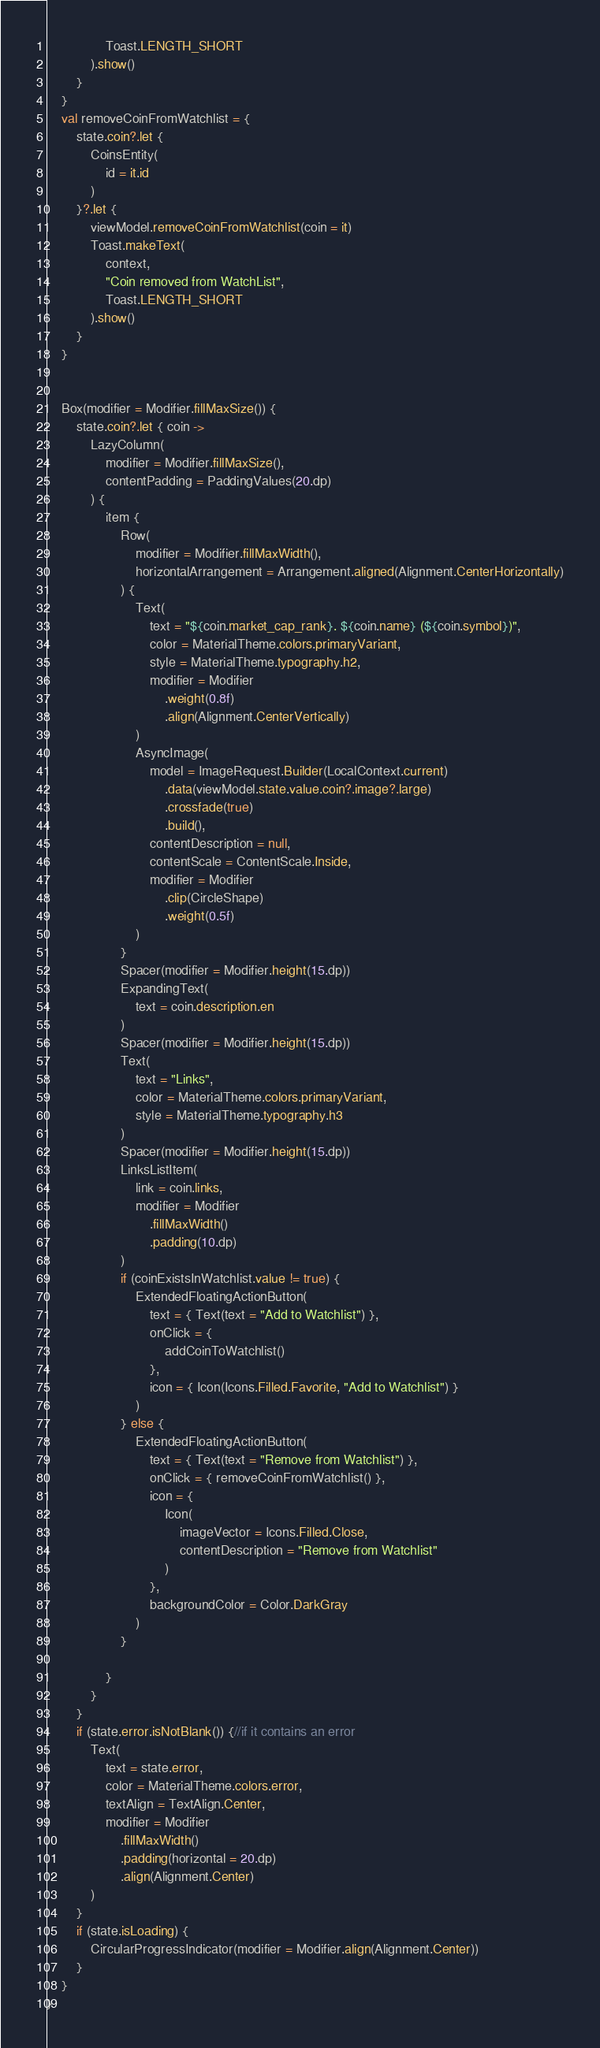Convert code to text. <code><loc_0><loc_0><loc_500><loc_500><_Kotlin_>                Toast.LENGTH_SHORT
            ).show()
        }
    }
    val removeCoinFromWatchlist = {
        state.coin?.let {
            CoinsEntity(
                id = it.id
            )
        }?.let {
            viewModel.removeCoinFromWatchlist(coin = it)
            Toast.makeText(
                context,
                "Coin removed from WatchList",
                Toast.LENGTH_SHORT
            ).show()
        }
    }


    Box(modifier = Modifier.fillMaxSize()) {
        state.coin?.let { coin ->
            LazyColumn(
                modifier = Modifier.fillMaxSize(),
                contentPadding = PaddingValues(20.dp)
            ) {
                item {
                    Row(
                        modifier = Modifier.fillMaxWidth(),
                        horizontalArrangement = Arrangement.aligned(Alignment.CenterHorizontally)
                    ) {
                        Text(
                            text = "${coin.market_cap_rank}. ${coin.name} (${coin.symbol})",
                            color = MaterialTheme.colors.primaryVariant,
                            style = MaterialTheme.typography.h2,
                            modifier = Modifier
                                .weight(0.8f)
                                .align(Alignment.CenterVertically)
                        )
                        AsyncImage(
                            model = ImageRequest.Builder(LocalContext.current)
                                .data(viewModel.state.value.coin?.image?.large)
                                .crossfade(true)
                                .build(),
                            contentDescription = null,
                            contentScale = ContentScale.Inside,
                            modifier = Modifier
                                .clip(CircleShape)
                                .weight(0.5f)
                        )
                    }
                    Spacer(modifier = Modifier.height(15.dp))
                    ExpandingText(
                        text = coin.description.en
                    )
                    Spacer(modifier = Modifier.height(15.dp))
                    Text(
                        text = "Links",
                        color = MaterialTheme.colors.primaryVariant,
                        style = MaterialTheme.typography.h3
                    )
                    Spacer(modifier = Modifier.height(15.dp))
                    LinksListItem(
                        link = coin.links,
                        modifier = Modifier
                            .fillMaxWidth()
                            .padding(10.dp)
                    )
                    if (coinExistsInWatchlist.value != true) {
                        ExtendedFloatingActionButton(
                            text = { Text(text = "Add to Watchlist") },
                            onClick = {
                                addCoinToWatchlist()
                            },
                            icon = { Icon(Icons.Filled.Favorite, "Add to Watchlist") }
                        )
                    } else {
                        ExtendedFloatingActionButton(
                            text = { Text(text = "Remove from Watchlist") },
                            onClick = { removeCoinFromWatchlist() },
                            icon = {
                                Icon(
                                    imageVector = Icons.Filled.Close,
                                    contentDescription = "Remove from Watchlist"
                                )
                            },
                            backgroundColor = Color.DarkGray
                        )
                    }

                }
            }
        }
        if (state.error.isNotBlank()) {//if it contains an error
            Text(
                text = state.error,
                color = MaterialTheme.colors.error,
                textAlign = TextAlign.Center,
                modifier = Modifier
                    .fillMaxWidth()
                    .padding(horizontal = 20.dp)
                    .align(Alignment.Center)
            )
        }
        if (state.isLoading) {
            CircularProgressIndicator(modifier = Modifier.align(Alignment.Center))
        }
    }
}</code> 